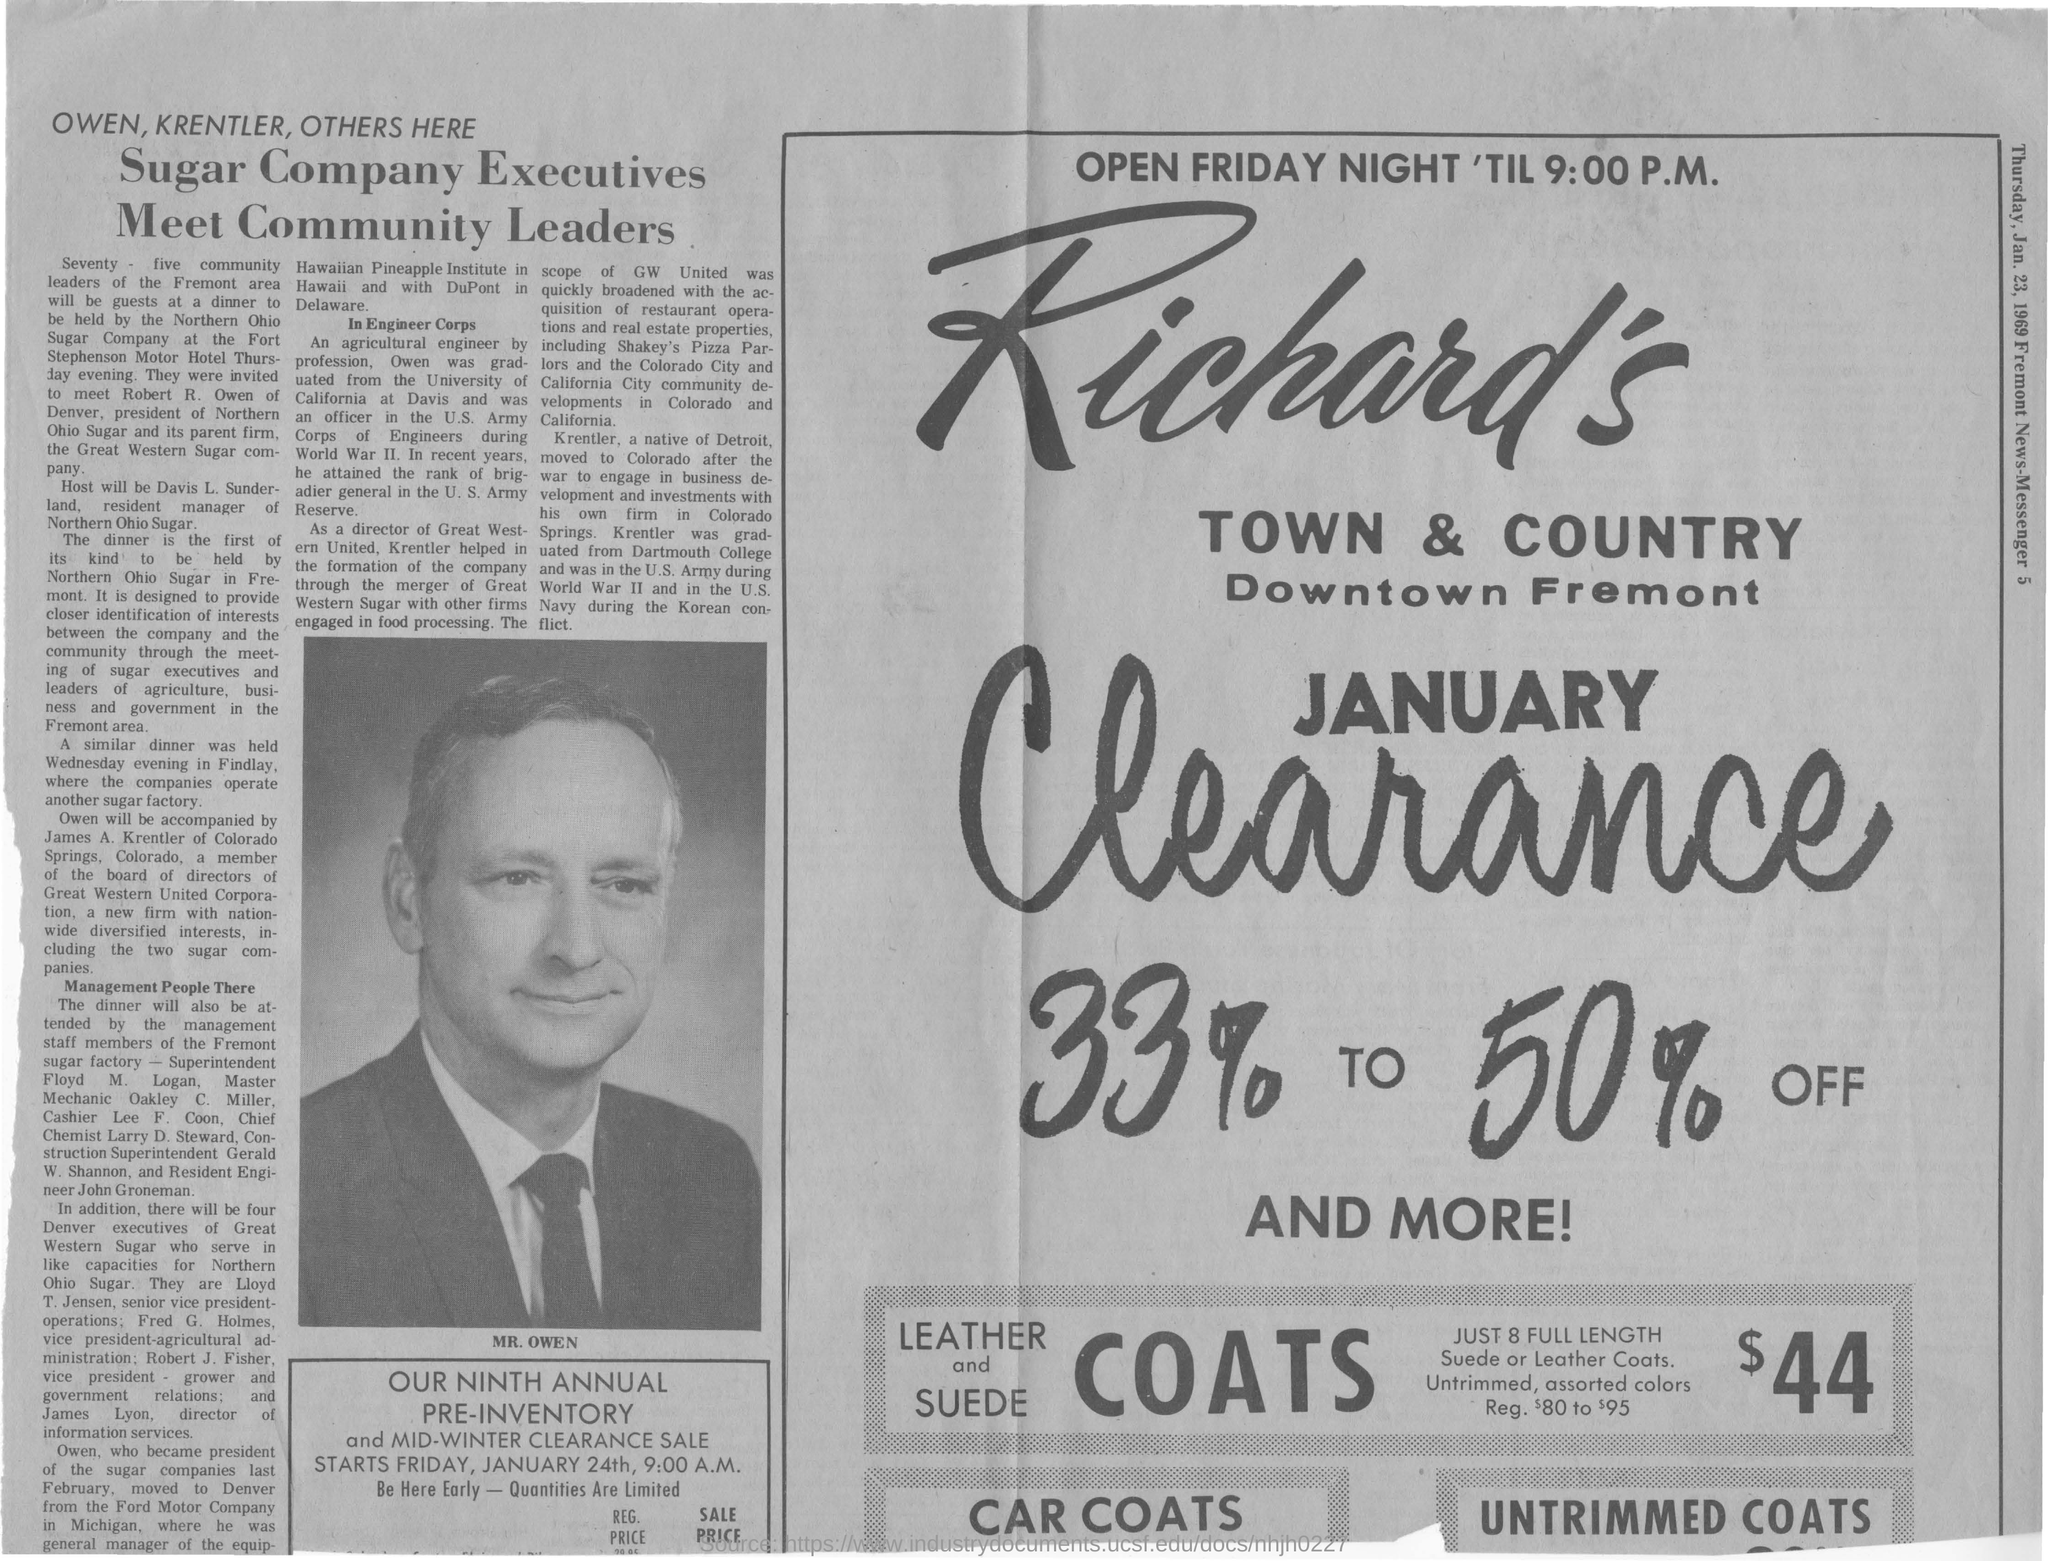Indicate a few pertinent items in this graphic. Seventy-five community leaders from the Fremont area are expected to be guests at the dinner. The executives of a sugar company met with community leaders. Owen was graduated from the University of California at Davis. 